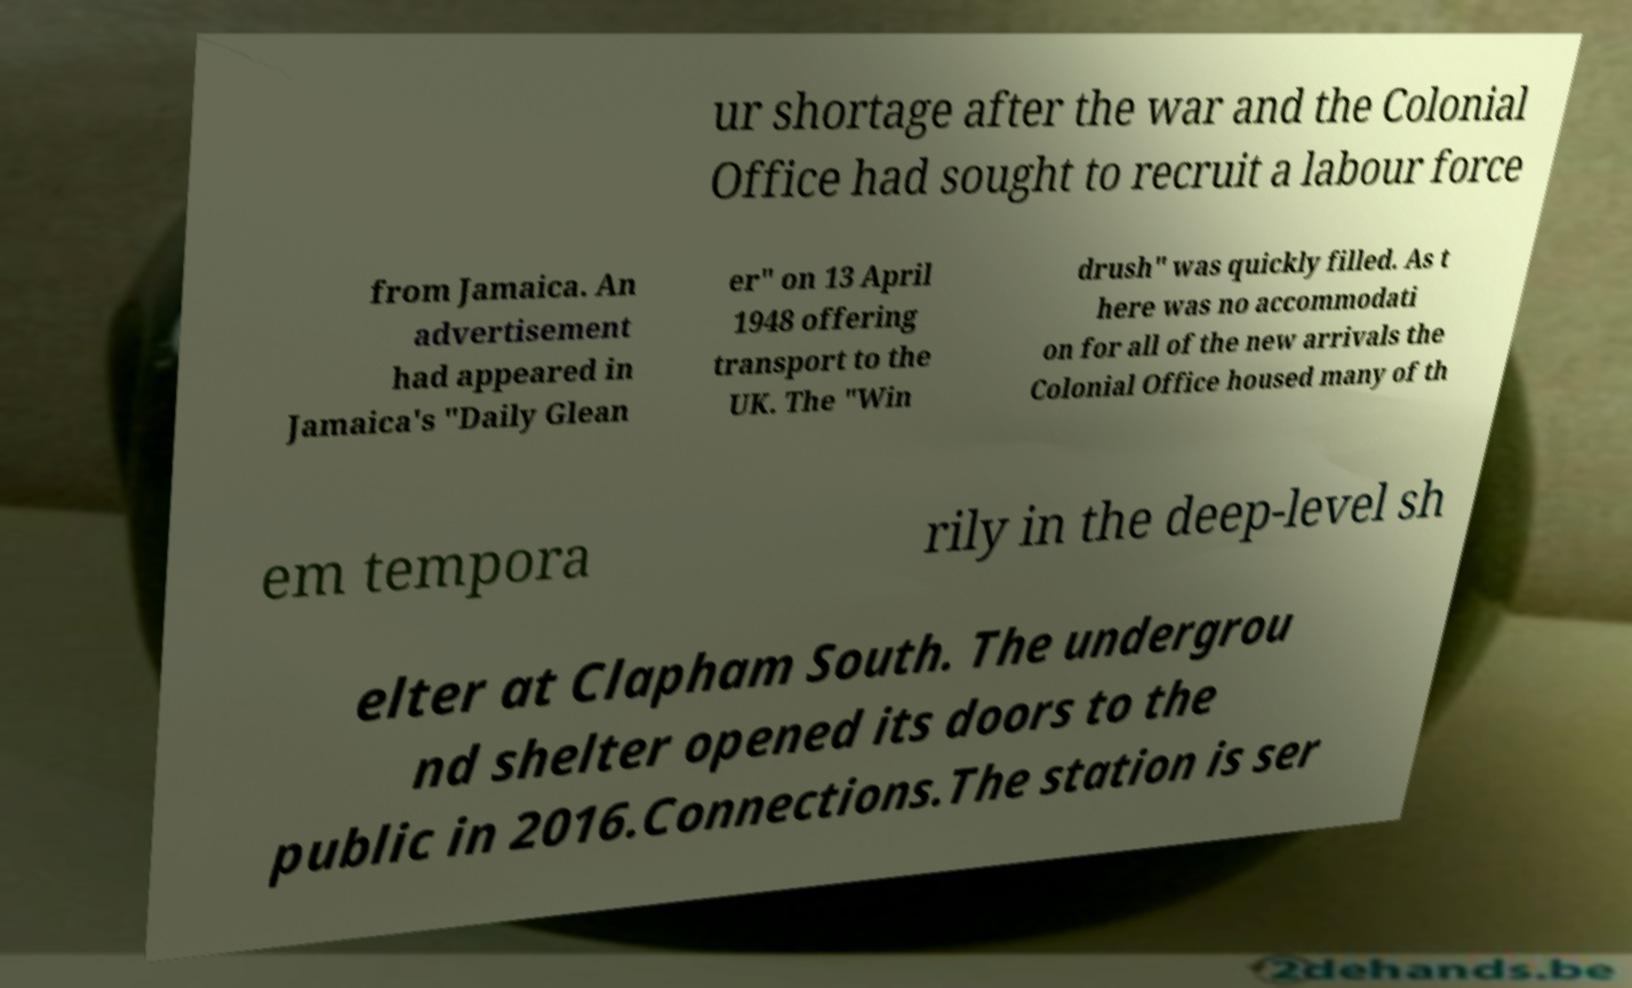What messages or text are displayed in this image? I need them in a readable, typed format. ur shortage after the war and the Colonial Office had sought to recruit a labour force from Jamaica. An advertisement had appeared in Jamaica's "Daily Glean er" on 13 April 1948 offering transport to the UK. The "Win drush" was quickly filled. As t here was no accommodati on for all of the new arrivals the Colonial Office housed many of th em tempora rily in the deep-level sh elter at Clapham South. The undergrou nd shelter opened its doors to the public in 2016.Connections.The station is ser 